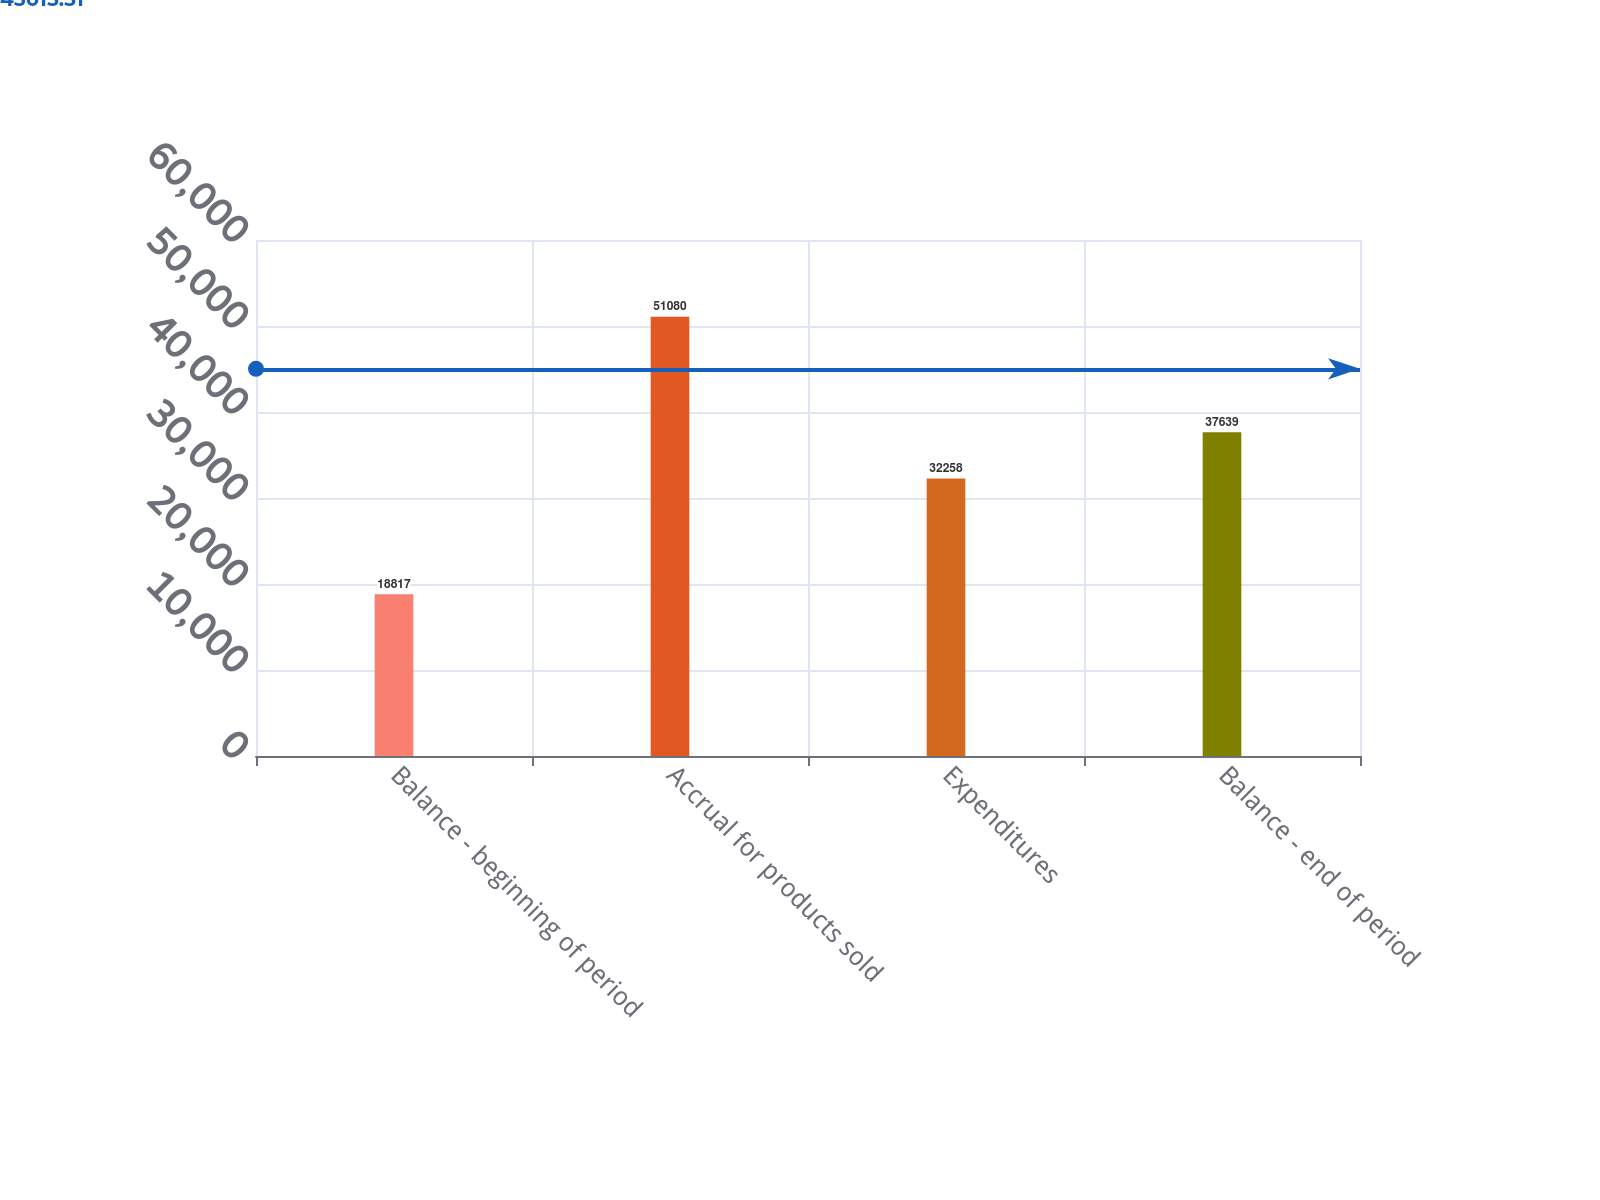<chart> <loc_0><loc_0><loc_500><loc_500><bar_chart><fcel>Balance - beginning of period<fcel>Accrual for products sold<fcel>Expenditures<fcel>Balance - end of period<nl><fcel>18817<fcel>51080<fcel>32258<fcel>37639<nl></chart> 